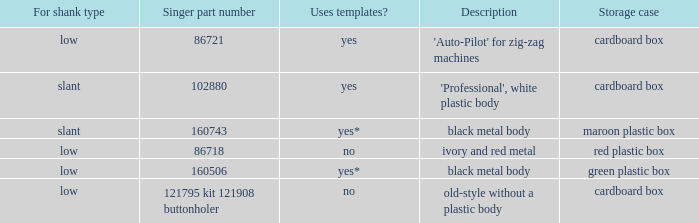What's the shank type of the buttonholer with red plastic box as storage case? Low. 